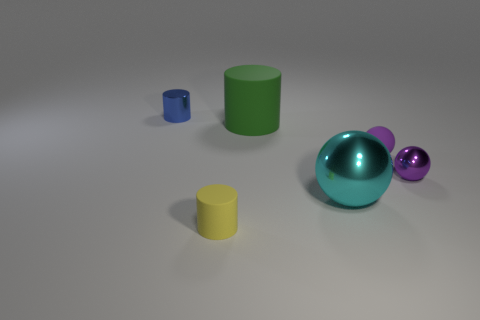Is there anything else that is made of the same material as the cyan thing?
Your answer should be compact. Yes. There is a tiny metal thing that is in front of the large green matte cylinder; what is its color?
Your answer should be compact. Purple. Is the number of large green matte objects that are in front of the purple shiny sphere the same as the number of yellow things?
Your answer should be very brief. No. How many other objects are there of the same shape as the tiny purple shiny thing?
Provide a succinct answer. 2. What number of yellow things are behind the cyan ball?
Provide a succinct answer. 0. There is a cylinder that is both on the left side of the large cylinder and behind the yellow cylinder; how big is it?
Provide a succinct answer. Small. Is there a small cylinder?
Provide a short and direct response. Yes. What number of other things are there of the same size as the purple matte object?
Ensure brevity in your answer.  3. Is the color of the tiny cylinder that is right of the tiny blue metallic object the same as the tiny metallic object that is to the right of the large cyan shiny sphere?
Provide a succinct answer. No. There is a yellow object that is the same shape as the blue thing; what is its size?
Give a very brief answer. Small. 